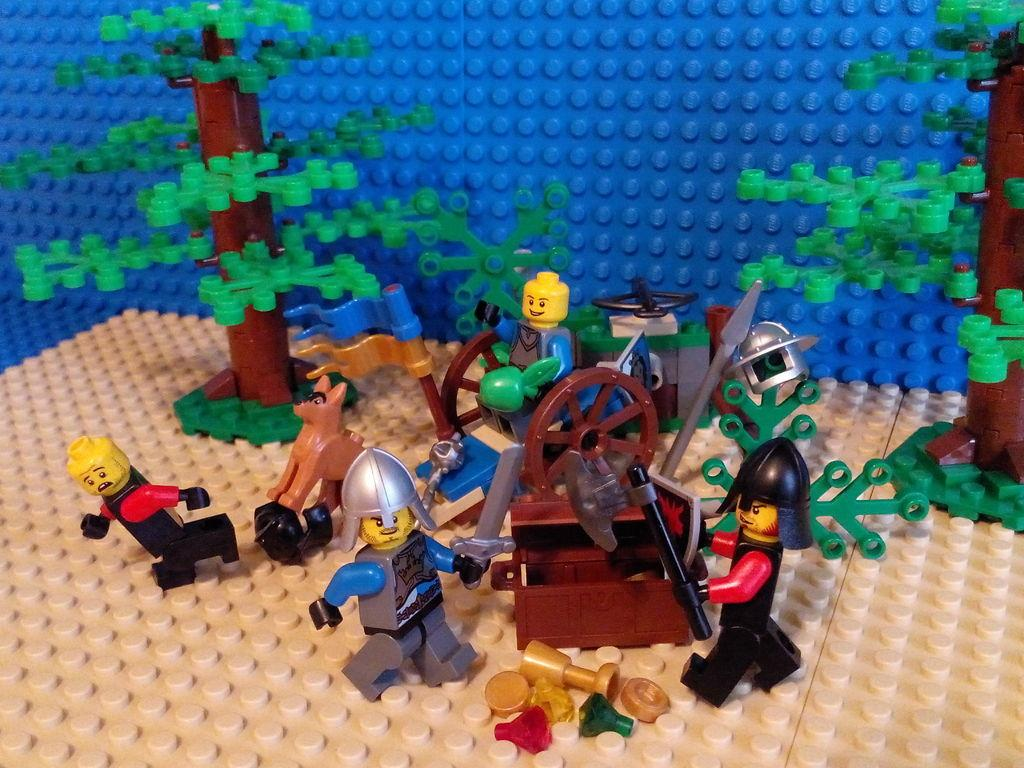What type of objects are present in the image? There are toys in the image. What feature can be observed on the toys? There are wheels visible on the toys. What other characteristic can be seen on the toys? There are weapons visible on the toys. Can you tell me how many pairs of feet are visible on the toys in the image? There is no reference to feet or shoes on the toys in the image. What type of tool is being used to cut the toys in the image? There is no tool, such as scissors, present in the image, nor is there any indication that the toys are being cut. 